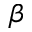Convert formula to latex. <formula><loc_0><loc_0><loc_500><loc_500>\beta</formula> 